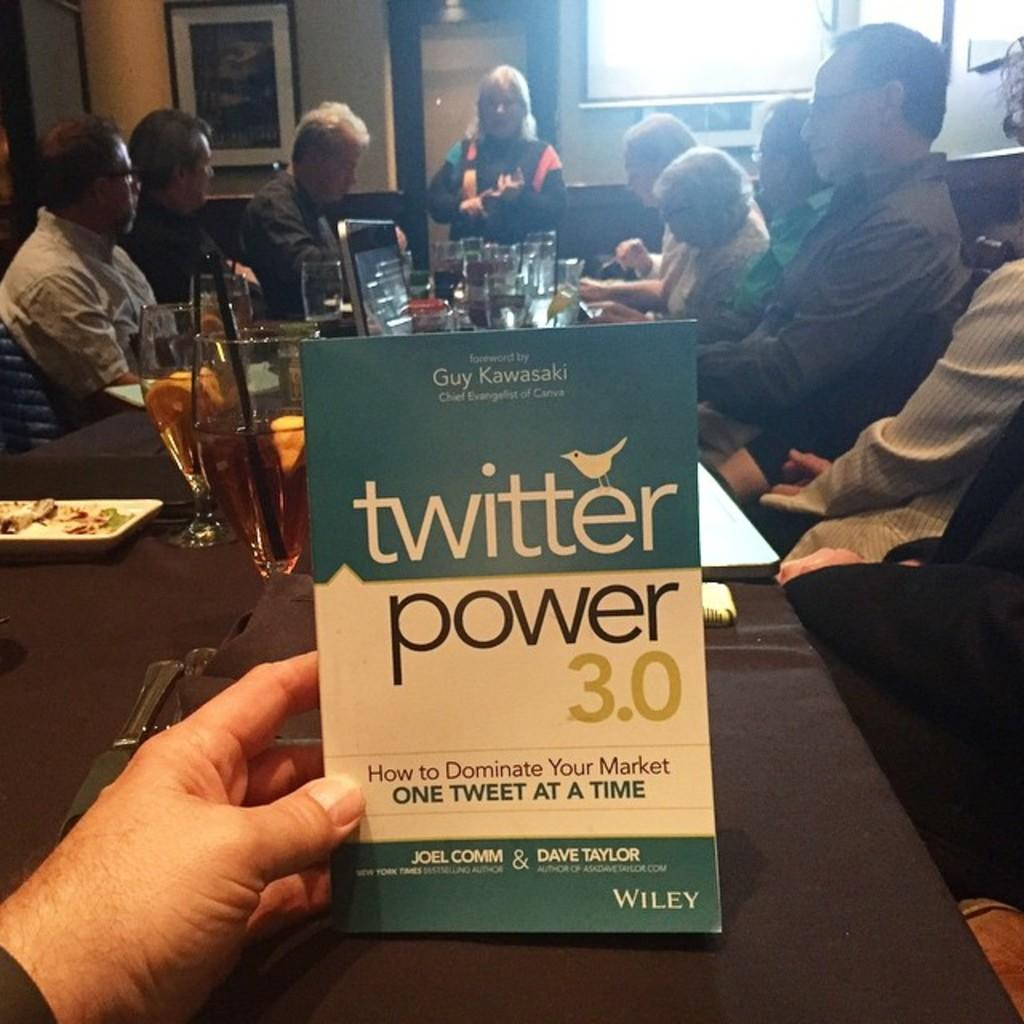<image>
Offer a succinct explanation of the picture presented. A person at a bar is holding an informational, business book titled Twitter Power 3.0. 